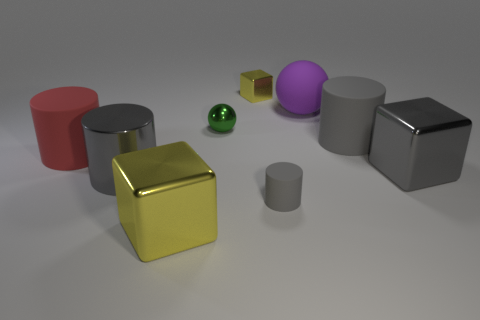Subtract all red balls. How many gray cylinders are left? 3 Add 1 large brown matte balls. How many objects exist? 10 Subtract all cylinders. How many objects are left? 5 Add 3 big gray metal cylinders. How many big gray metal cylinders exist? 4 Subtract 1 gray blocks. How many objects are left? 8 Subtract all green cylinders. Subtract all large matte balls. How many objects are left? 8 Add 1 large matte cylinders. How many large matte cylinders are left? 3 